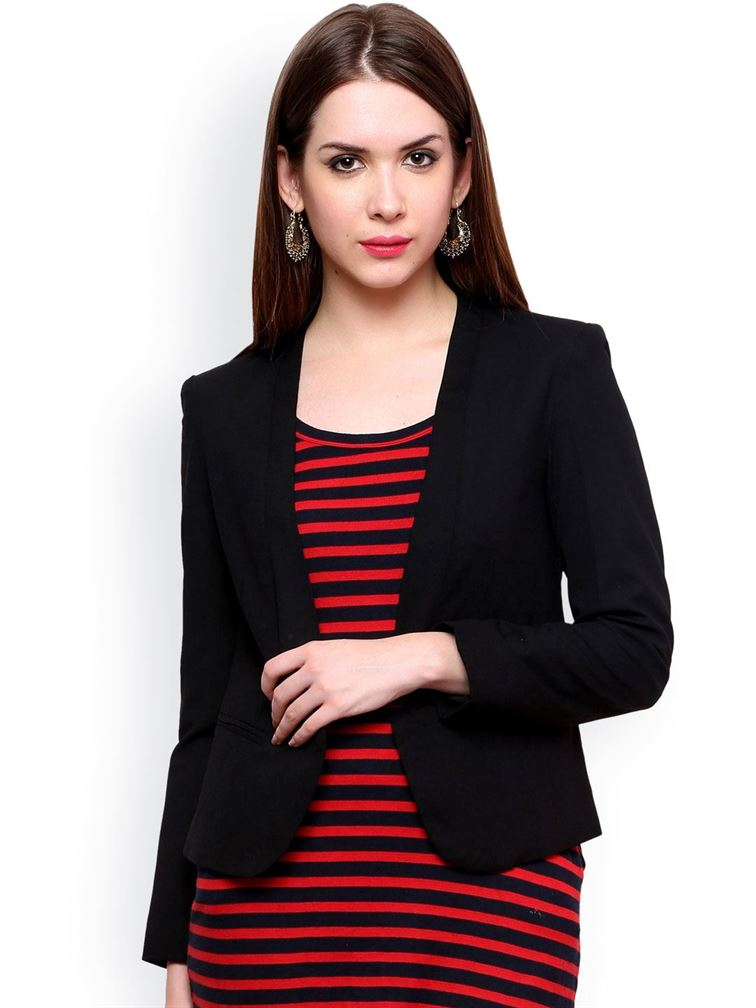What is the possible material of the earrings based on their appearance? The earrings worn by the woman have a glossy and reflective finish, hinting that they are likely made of a polished metal. Based on the shine and color, they could be crafted from a gold-tone alloy, or perhaps they are gold-plated, providing the luxurious golden appearance without the significant cost of solid gold. The intricate design of the earrings also supports the idea that they might not be pure gold, as solid gold is often less detailed due to its softness. Hence, it is reasonable to conclude that the earrings are most likely made from a gold-colored metal alloy or are gold-plated. 